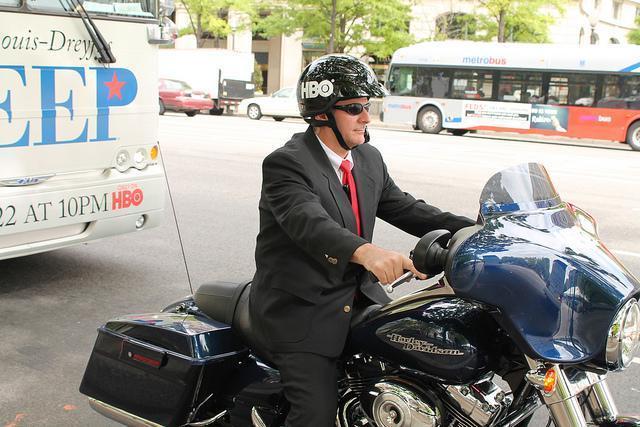How many buses can you see?
Give a very brief answer. 2. 